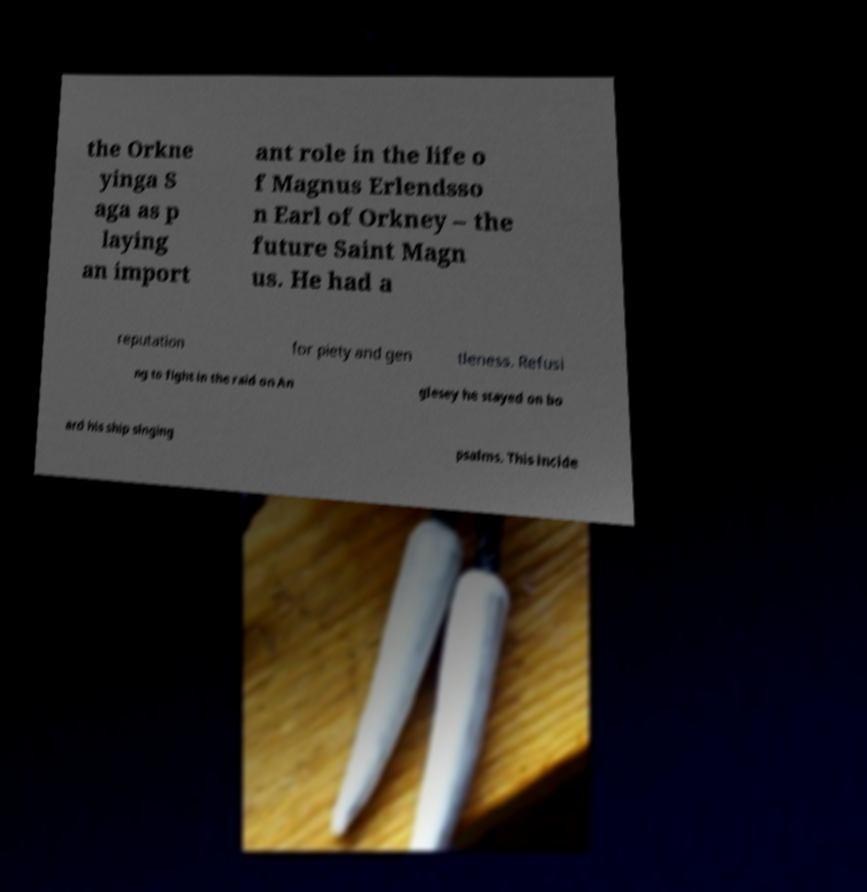Can you read and provide the text displayed in the image?This photo seems to have some interesting text. Can you extract and type it out for me? the Orkne yinga S aga as p laying an import ant role in the life o f Magnus Erlendsso n Earl of Orkney – the future Saint Magn us. He had a reputation for piety and gen tleness. Refusi ng to fight in the raid on An glesey he stayed on bo ard his ship singing psalms. This incide 